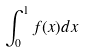Convert formula to latex. <formula><loc_0><loc_0><loc_500><loc_500>\int _ { 0 } ^ { 1 } f ( x ) d x</formula> 